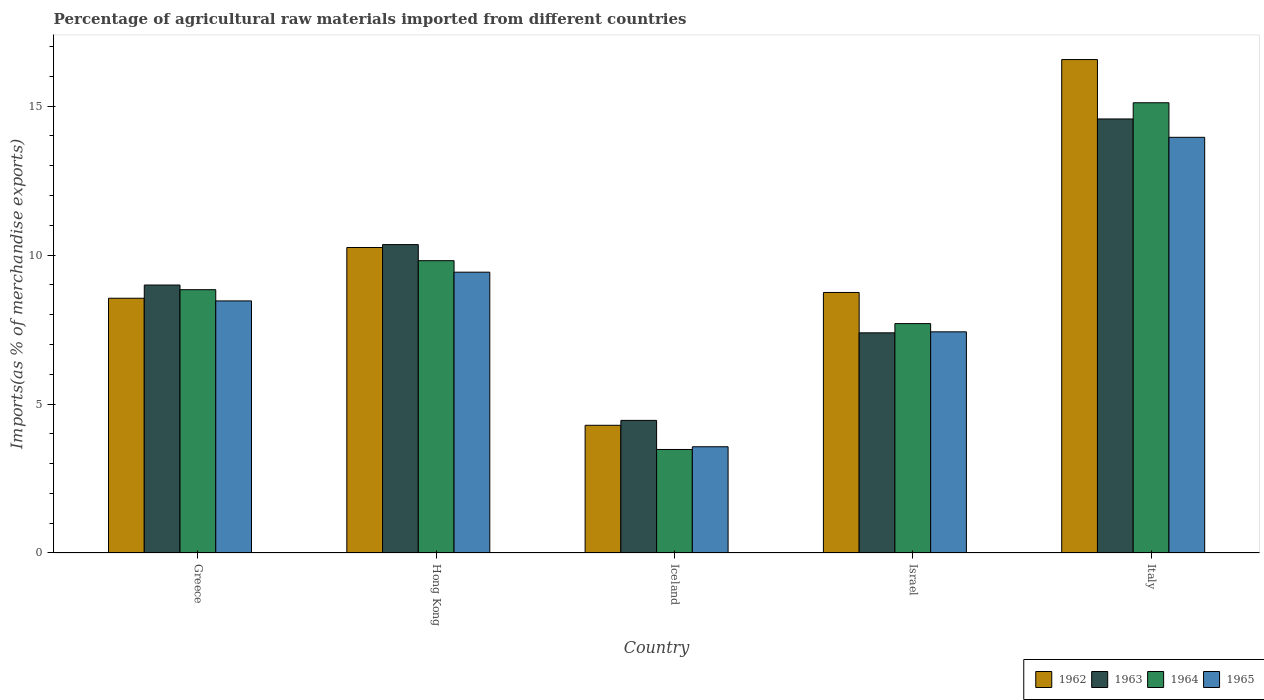How many groups of bars are there?
Make the answer very short. 5. Are the number of bars per tick equal to the number of legend labels?
Keep it short and to the point. Yes. What is the label of the 1st group of bars from the left?
Give a very brief answer. Greece. In how many cases, is the number of bars for a given country not equal to the number of legend labels?
Provide a succinct answer. 0. What is the percentage of imports to different countries in 1962 in Greece?
Give a very brief answer. 8.55. Across all countries, what is the maximum percentage of imports to different countries in 1963?
Your answer should be very brief. 14.57. Across all countries, what is the minimum percentage of imports to different countries in 1964?
Your answer should be very brief. 3.48. What is the total percentage of imports to different countries in 1962 in the graph?
Make the answer very short. 48.41. What is the difference between the percentage of imports to different countries in 1963 in Israel and that in Italy?
Ensure brevity in your answer.  -7.18. What is the difference between the percentage of imports to different countries in 1965 in Israel and the percentage of imports to different countries in 1962 in Italy?
Provide a short and direct response. -9.14. What is the average percentage of imports to different countries in 1964 per country?
Provide a short and direct response. 8.99. What is the difference between the percentage of imports to different countries of/in 1965 and percentage of imports to different countries of/in 1962 in Israel?
Make the answer very short. -1.32. What is the ratio of the percentage of imports to different countries in 1962 in Greece to that in Israel?
Give a very brief answer. 0.98. Is the difference between the percentage of imports to different countries in 1965 in Greece and Italy greater than the difference between the percentage of imports to different countries in 1962 in Greece and Italy?
Make the answer very short. Yes. What is the difference between the highest and the second highest percentage of imports to different countries in 1964?
Offer a terse response. -0.97. What is the difference between the highest and the lowest percentage of imports to different countries in 1963?
Provide a succinct answer. 10.12. In how many countries, is the percentage of imports to different countries in 1964 greater than the average percentage of imports to different countries in 1964 taken over all countries?
Your response must be concise. 2. Is the sum of the percentage of imports to different countries in 1963 in Iceland and Israel greater than the maximum percentage of imports to different countries in 1965 across all countries?
Give a very brief answer. No. What does the 4th bar from the left in Iceland represents?
Give a very brief answer. 1965. How many bars are there?
Offer a terse response. 20. Are all the bars in the graph horizontal?
Your answer should be compact. No. How many countries are there in the graph?
Your response must be concise. 5. What is the difference between two consecutive major ticks on the Y-axis?
Provide a succinct answer. 5. How many legend labels are there?
Ensure brevity in your answer.  4. What is the title of the graph?
Offer a terse response. Percentage of agricultural raw materials imported from different countries. What is the label or title of the X-axis?
Offer a terse response. Country. What is the label or title of the Y-axis?
Provide a succinct answer. Imports(as % of merchandise exports). What is the Imports(as % of merchandise exports) of 1962 in Greece?
Keep it short and to the point. 8.55. What is the Imports(as % of merchandise exports) of 1963 in Greece?
Your answer should be very brief. 9. What is the Imports(as % of merchandise exports) of 1964 in Greece?
Your answer should be compact. 8.84. What is the Imports(as % of merchandise exports) of 1965 in Greece?
Make the answer very short. 8.46. What is the Imports(as % of merchandise exports) of 1962 in Hong Kong?
Offer a terse response. 10.26. What is the Imports(as % of merchandise exports) of 1963 in Hong Kong?
Provide a short and direct response. 10.35. What is the Imports(as % of merchandise exports) of 1964 in Hong Kong?
Offer a terse response. 9.81. What is the Imports(as % of merchandise exports) in 1965 in Hong Kong?
Offer a very short reply. 9.43. What is the Imports(as % of merchandise exports) of 1962 in Iceland?
Offer a very short reply. 4.29. What is the Imports(as % of merchandise exports) of 1963 in Iceland?
Provide a succinct answer. 4.45. What is the Imports(as % of merchandise exports) of 1964 in Iceland?
Provide a short and direct response. 3.48. What is the Imports(as % of merchandise exports) of 1965 in Iceland?
Provide a short and direct response. 3.57. What is the Imports(as % of merchandise exports) of 1962 in Israel?
Provide a short and direct response. 8.75. What is the Imports(as % of merchandise exports) in 1963 in Israel?
Offer a terse response. 7.39. What is the Imports(as % of merchandise exports) of 1964 in Israel?
Give a very brief answer. 7.7. What is the Imports(as % of merchandise exports) in 1965 in Israel?
Your answer should be very brief. 7.42. What is the Imports(as % of merchandise exports) in 1962 in Italy?
Provide a short and direct response. 16.57. What is the Imports(as % of merchandise exports) of 1963 in Italy?
Give a very brief answer. 14.57. What is the Imports(as % of merchandise exports) of 1964 in Italy?
Offer a very short reply. 15.12. What is the Imports(as % of merchandise exports) of 1965 in Italy?
Make the answer very short. 13.95. Across all countries, what is the maximum Imports(as % of merchandise exports) in 1962?
Give a very brief answer. 16.57. Across all countries, what is the maximum Imports(as % of merchandise exports) in 1963?
Your answer should be compact. 14.57. Across all countries, what is the maximum Imports(as % of merchandise exports) of 1964?
Make the answer very short. 15.12. Across all countries, what is the maximum Imports(as % of merchandise exports) of 1965?
Offer a terse response. 13.95. Across all countries, what is the minimum Imports(as % of merchandise exports) of 1962?
Provide a short and direct response. 4.29. Across all countries, what is the minimum Imports(as % of merchandise exports) in 1963?
Provide a short and direct response. 4.45. Across all countries, what is the minimum Imports(as % of merchandise exports) of 1964?
Give a very brief answer. 3.48. Across all countries, what is the minimum Imports(as % of merchandise exports) of 1965?
Ensure brevity in your answer.  3.57. What is the total Imports(as % of merchandise exports) of 1962 in the graph?
Your response must be concise. 48.41. What is the total Imports(as % of merchandise exports) in 1963 in the graph?
Your answer should be compact. 45.76. What is the total Imports(as % of merchandise exports) of 1964 in the graph?
Offer a terse response. 44.94. What is the total Imports(as % of merchandise exports) in 1965 in the graph?
Provide a short and direct response. 42.84. What is the difference between the Imports(as % of merchandise exports) of 1962 in Greece and that in Hong Kong?
Your answer should be very brief. -1.7. What is the difference between the Imports(as % of merchandise exports) in 1963 in Greece and that in Hong Kong?
Ensure brevity in your answer.  -1.36. What is the difference between the Imports(as % of merchandise exports) of 1964 in Greece and that in Hong Kong?
Provide a short and direct response. -0.97. What is the difference between the Imports(as % of merchandise exports) of 1965 in Greece and that in Hong Kong?
Your answer should be compact. -0.96. What is the difference between the Imports(as % of merchandise exports) of 1962 in Greece and that in Iceland?
Give a very brief answer. 4.26. What is the difference between the Imports(as % of merchandise exports) of 1963 in Greece and that in Iceland?
Offer a very short reply. 4.54. What is the difference between the Imports(as % of merchandise exports) of 1964 in Greece and that in Iceland?
Give a very brief answer. 5.36. What is the difference between the Imports(as % of merchandise exports) of 1965 in Greece and that in Iceland?
Give a very brief answer. 4.9. What is the difference between the Imports(as % of merchandise exports) in 1962 in Greece and that in Israel?
Offer a terse response. -0.19. What is the difference between the Imports(as % of merchandise exports) in 1963 in Greece and that in Israel?
Offer a very short reply. 1.6. What is the difference between the Imports(as % of merchandise exports) in 1964 in Greece and that in Israel?
Give a very brief answer. 1.14. What is the difference between the Imports(as % of merchandise exports) of 1965 in Greece and that in Israel?
Offer a very short reply. 1.04. What is the difference between the Imports(as % of merchandise exports) of 1962 in Greece and that in Italy?
Provide a short and direct response. -8.01. What is the difference between the Imports(as % of merchandise exports) of 1963 in Greece and that in Italy?
Your answer should be very brief. -5.58. What is the difference between the Imports(as % of merchandise exports) in 1964 in Greece and that in Italy?
Ensure brevity in your answer.  -6.28. What is the difference between the Imports(as % of merchandise exports) of 1965 in Greece and that in Italy?
Make the answer very short. -5.49. What is the difference between the Imports(as % of merchandise exports) of 1962 in Hong Kong and that in Iceland?
Keep it short and to the point. 5.97. What is the difference between the Imports(as % of merchandise exports) in 1963 in Hong Kong and that in Iceland?
Your response must be concise. 5.9. What is the difference between the Imports(as % of merchandise exports) of 1964 in Hong Kong and that in Iceland?
Provide a succinct answer. 6.34. What is the difference between the Imports(as % of merchandise exports) in 1965 in Hong Kong and that in Iceland?
Your answer should be very brief. 5.86. What is the difference between the Imports(as % of merchandise exports) in 1962 in Hong Kong and that in Israel?
Provide a short and direct response. 1.51. What is the difference between the Imports(as % of merchandise exports) in 1963 in Hong Kong and that in Israel?
Give a very brief answer. 2.96. What is the difference between the Imports(as % of merchandise exports) of 1964 in Hong Kong and that in Israel?
Provide a succinct answer. 2.11. What is the difference between the Imports(as % of merchandise exports) in 1965 in Hong Kong and that in Israel?
Provide a succinct answer. 2. What is the difference between the Imports(as % of merchandise exports) of 1962 in Hong Kong and that in Italy?
Your answer should be compact. -6.31. What is the difference between the Imports(as % of merchandise exports) of 1963 in Hong Kong and that in Italy?
Ensure brevity in your answer.  -4.22. What is the difference between the Imports(as % of merchandise exports) in 1964 in Hong Kong and that in Italy?
Keep it short and to the point. -5.3. What is the difference between the Imports(as % of merchandise exports) of 1965 in Hong Kong and that in Italy?
Your answer should be compact. -4.53. What is the difference between the Imports(as % of merchandise exports) of 1962 in Iceland and that in Israel?
Keep it short and to the point. -4.46. What is the difference between the Imports(as % of merchandise exports) of 1963 in Iceland and that in Israel?
Your response must be concise. -2.94. What is the difference between the Imports(as % of merchandise exports) in 1964 in Iceland and that in Israel?
Provide a succinct answer. -4.23. What is the difference between the Imports(as % of merchandise exports) in 1965 in Iceland and that in Israel?
Your answer should be very brief. -3.86. What is the difference between the Imports(as % of merchandise exports) of 1962 in Iceland and that in Italy?
Make the answer very short. -12.28. What is the difference between the Imports(as % of merchandise exports) of 1963 in Iceland and that in Italy?
Make the answer very short. -10.12. What is the difference between the Imports(as % of merchandise exports) of 1964 in Iceland and that in Italy?
Make the answer very short. -11.64. What is the difference between the Imports(as % of merchandise exports) of 1965 in Iceland and that in Italy?
Your response must be concise. -10.39. What is the difference between the Imports(as % of merchandise exports) of 1962 in Israel and that in Italy?
Offer a very short reply. -7.82. What is the difference between the Imports(as % of merchandise exports) in 1963 in Israel and that in Italy?
Ensure brevity in your answer.  -7.18. What is the difference between the Imports(as % of merchandise exports) in 1964 in Israel and that in Italy?
Your response must be concise. -7.41. What is the difference between the Imports(as % of merchandise exports) of 1965 in Israel and that in Italy?
Ensure brevity in your answer.  -6.53. What is the difference between the Imports(as % of merchandise exports) of 1962 in Greece and the Imports(as % of merchandise exports) of 1963 in Hong Kong?
Offer a very short reply. -1.8. What is the difference between the Imports(as % of merchandise exports) of 1962 in Greece and the Imports(as % of merchandise exports) of 1964 in Hong Kong?
Your answer should be very brief. -1.26. What is the difference between the Imports(as % of merchandise exports) of 1962 in Greece and the Imports(as % of merchandise exports) of 1965 in Hong Kong?
Provide a short and direct response. -0.88. What is the difference between the Imports(as % of merchandise exports) in 1963 in Greece and the Imports(as % of merchandise exports) in 1964 in Hong Kong?
Ensure brevity in your answer.  -0.82. What is the difference between the Imports(as % of merchandise exports) in 1963 in Greece and the Imports(as % of merchandise exports) in 1965 in Hong Kong?
Give a very brief answer. -0.43. What is the difference between the Imports(as % of merchandise exports) in 1964 in Greece and the Imports(as % of merchandise exports) in 1965 in Hong Kong?
Provide a short and direct response. -0.59. What is the difference between the Imports(as % of merchandise exports) in 1962 in Greece and the Imports(as % of merchandise exports) in 1963 in Iceland?
Your answer should be very brief. 4.1. What is the difference between the Imports(as % of merchandise exports) in 1962 in Greece and the Imports(as % of merchandise exports) in 1964 in Iceland?
Offer a terse response. 5.08. What is the difference between the Imports(as % of merchandise exports) in 1962 in Greece and the Imports(as % of merchandise exports) in 1965 in Iceland?
Make the answer very short. 4.99. What is the difference between the Imports(as % of merchandise exports) of 1963 in Greece and the Imports(as % of merchandise exports) of 1964 in Iceland?
Your answer should be very brief. 5.52. What is the difference between the Imports(as % of merchandise exports) in 1963 in Greece and the Imports(as % of merchandise exports) in 1965 in Iceland?
Your answer should be compact. 5.43. What is the difference between the Imports(as % of merchandise exports) in 1964 in Greece and the Imports(as % of merchandise exports) in 1965 in Iceland?
Your answer should be compact. 5.27. What is the difference between the Imports(as % of merchandise exports) of 1962 in Greece and the Imports(as % of merchandise exports) of 1963 in Israel?
Make the answer very short. 1.16. What is the difference between the Imports(as % of merchandise exports) of 1962 in Greece and the Imports(as % of merchandise exports) of 1964 in Israel?
Your response must be concise. 0.85. What is the difference between the Imports(as % of merchandise exports) in 1962 in Greece and the Imports(as % of merchandise exports) in 1965 in Israel?
Keep it short and to the point. 1.13. What is the difference between the Imports(as % of merchandise exports) in 1963 in Greece and the Imports(as % of merchandise exports) in 1964 in Israel?
Provide a succinct answer. 1.3. What is the difference between the Imports(as % of merchandise exports) of 1963 in Greece and the Imports(as % of merchandise exports) of 1965 in Israel?
Keep it short and to the point. 1.57. What is the difference between the Imports(as % of merchandise exports) in 1964 in Greece and the Imports(as % of merchandise exports) in 1965 in Israel?
Ensure brevity in your answer.  1.42. What is the difference between the Imports(as % of merchandise exports) in 1962 in Greece and the Imports(as % of merchandise exports) in 1963 in Italy?
Your answer should be very brief. -6.02. What is the difference between the Imports(as % of merchandise exports) of 1962 in Greece and the Imports(as % of merchandise exports) of 1964 in Italy?
Make the answer very short. -6.56. What is the difference between the Imports(as % of merchandise exports) in 1962 in Greece and the Imports(as % of merchandise exports) in 1965 in Italy?
Ensure brevity in your answer.  -5.4. What is the difference between the Imports(as % of merchandise exports) of 1963 in Greece and the Imports(as % of merchandise exports) of 1964 in Italy?
Your answer should be very brief. -6.12. What is the difference between the Imports(as % of merchandise exports) in 1963 in Greece and the Imports(as % of merchandise exports) in 1965 in Italy?
Ensure brevity in your answer.  -4.96. What is the difference between the Imports(as % of merchandise exports) in 1964 in Greece and the Imports(as % of merchandise exports) in 1965 in Italy?
Make the answer very short. -5.12. What is the difference between the Imports(as % of merchandise exports) in 1962 in Hong Kong and the Imports(as % of merchandise exports) in 1963 in Iceland?
Make the answer very short. 5.8. What is the difference between the Imports(as % of merchandise exports) of 1962 in Hong Kong and the Imports(as % of merchandise exports) of 1964 in Iceland?
Offer a very short reply. 6.78. What is the difference between the Imports(as % of merchandise exports) of 1962 in Hong Kong and the Imports(as % of merchandise exports) of 1965 in Iceland?
Offer a terse response. 6.69. What is the difference between the Imports(as % of merchandise exports) in 1963 in Hong Kong and the Imports(as % of merchandise exports) in 1964 in Iceland?
Provide a succinct answer. 6.88. What is the difference between the Imports(as % of merchandise exports) in 1963 in Hong Kong and the Imports(as % of merchandise exports) in 1965 in Iceland?
Offer a very short reply. 6.79. What is the difference between the Imports(as % of merchandise exports) in 1964 in Hong Kong and the Imports(as % of merchandise exports) in 1965 in Iceland?
Ensure brevity in your answer.  6.25. What is the difference between the Imports(as % of merchandise exports) of 1962 in Hong Kong and the Imports(as % of merchandise exports) of 1963 in Israel?
Provide a succinct answer. 2.86. What is the difference between the Imports(as % of merchandise exports) in 1962 in Hong Kong and the Imports(as % of merchandise exports) in 1964 in Israel?
Provide a short and direct response. 2.55. What is the difference between the Imports(as % of merchandise exports) in 1962 in Hong Kong and the Imports(as % of merchandise exports) in 1965 in Israel?
Provide a succinct answer. 2.83. What is the difference between the Imports(as % of merchandise exports) of 1963 in Hong Kong and the Imports(as % of merchandise exports) of 1964 in Israel?
Ensure brevity in your answer.  2.65. What is the difference between the Imports(as % of merchandise exports) in 1963 in Hong Kong and the Imports(as % of merchandise exports) in 1965 in Israel?
Your answer should be compact. 2.93. What is the difference between the Imports(as % of merchandise exports) of 1964 in Hong Kong and the Imports(as % of merchandise exports) of 1965 in Israel?
Your answer should be compact. 2.39. What is the difference between the Imports(as % of merchandise exports) of 1962 in Hong Kong and the Imports(as % of merchandise exports) of 1963 in Italy?
Keep it short and to the point. -4.32. What is the difference between the Imports(as % of merchandise exports) in 1962 in Hong Kong and the Imports(as % of merchandise exports) in 1964 in Italy?
Ensure brevity in your answer.  -4.86. What is the difference between the Imports(as % of merchandise exports) of 1962 in Hong Kong and the Imports(as % of merchandise exports) of 1965 in Italy?
Your response must be concise. -3.7. What is the difference between the Imports(as % of merchandise exports) of 1963 in Hong Kong and the Imports(as % of merchandise exports) of 1964 in Italy?
Your answer should be very brief. -4.76. What is the difference between the Imports(as % of merchandise exports) of 1963 in Hong Kong and the Imports(as % of merchandise exports) of 1965 in Italy?
Your response must be concise. -3.6. What is the difference between the Imports(as % of merchandise exports) in 1964 in Hong Kong and the Imports(as % of merchandise exports) in 1965 in Italy?
Ensure brevity in your answer.  -4.14. What is the difference between the Imports(as % of merchandise exports) of 1962 in Iceland and the Imports(as % of merchandise exports) of 1963 in Israel?
Give a very brief answer. -3.1. What is the difference between the Imports(as % of merchandise exports) in 1962 in Iceland and the Imports(as % of merchandise exports) in 1964 in Israel?
Your answer should be very brief. -3.41. What is the difference between the Imports(as % of merchandise exports) of 1962 in Iceland and the Imports(as % of merchandise exports) of 1965 in Israel?
Your answer should be very brief. -3.14. What is the difference between the Imports(as % of merchandise exports) in 1963 in Iceland and the Imports(as % of merchandise exports) in 1964 in Israel?
Your answer should be very brief. -3.25. What is the difference between the Imports(as % of merchandise exports) in 1963 in Iceland and the Imports(as % of merchandise exports) in 1965 in Israel?
Ensure brevity in your answer.  -2.97. What is the difference between the Imports(as % of merchandise exports) in 1964 in Iceland and the Imports(as % of merchandise exports) in 1965 in Israel?
Give a very brief answer. -3.95. What is the difference between the Imports(as % of merchandise exports) in 1962 in Iceland and the Imports(as % of merchandise exports) in 1963 in Italy?
Provide a short and direct response. -10.28. What is the difference between the Imports(as % of merchandise exports) of 1962 in Iceland and the Imports(as % of merchandise exports) of 1964 in Italy?
Offer a terse response. -10.83. What is the difference between the Imports(as % of merchandise exports) in 1962 in Iceland and the Imports(as % of merchandise exports) in 1965 in Italy?
Give a very brief answer. -9.67. What is the difference between the Imports(as % of merchandise exports) of 1963 in Iceland and the Imports(as % of merchandise exports) of 1964 in Italy?
Offer a terse response. -10.66. What is the difference between the Imports(as % of merchandise exports) in 1963 in Iceland and the Imports(as % of merchandise exports) in 1965 in Italy?
Offer a very short reply. -9.5. What is the difference between the Imports(as % of merchandise exports) of 1964 in Iceland and the Imports(as % of merchandise exports) of 1965 in Italy?
Offer a very short reply. -10.48. What is the difference between the Imports(as % of merchandise exports) of 1962 in Israel and the Imports(as % of merchandise exports) of 1963 in Italy?
Your response must be concise. -5.83. What is the difference between the Imports(as % of merchandise exports) in 1962 in Israel and the Imports(as % of merchandise exports) in 1964 in Italy?
Keep it short and to the point. -6.37. What is the difference between the Imports(as % of merchandise exports) in 1962 in Israel and the Imports(as % of merchandise exports) in 1965 in Italy?
Offer a very short reply. -5.21. What is the difference between the Imports(as % of merchandise exports) in 1963 in Israel and the Imports(as % of merchandise exports) in 1964 in Italy?
Give a very brief answer. -7.72. What is the difference between the Imports(as % of merchandise exports) of 1963 in Israel and the Imports(as % of merchandise exports) of 1965 in Italy?
Offer a terse response. -6.56. What is the difference between the Imports(as % of merchandise exports) of 1964 in Israel and the Imports(as % of merchandise exports) of 1965 in Italy?
Offer a very short reply. -6.25. What is the average Imports(as % of merchandise exports) of 1962 per country?
Keep it short and to the point. 9.68. What is the average Imports(as % of merchandise exports) of 1963 per country?
Keep it short and to the point. 9.15. What is the average Imports(as % of merchandise exports) of 1964 per country?
Give a very brief answer. 8.99. What is the average Imports(as % of merchandise exports) of 1965 per country?
Offer a terse response. 8.57. What is the difference between the Imports(as % of merchandise exports) in 1962 and Imports(as % of merchandise exports) in 1963 in Greece?
Offer a very short reply. -0.44. What is the difference between the Imports(as % of merchandise exports) in 1962 and Imports(as % of merchandise exports) in 1964 in Greece?
Provide a succinct answer. -0.29. What is the difference between the Imports(as % of merchandise exports) in 1962 and Imports(as % of merchandise exports) in 1965 in Greece?
Your response must be concise. 0.09. What is the difference between the Imports(as % of merchandise exports) of 1963 and Imports(as % of merchandise exports) of 1964 in Greece?
Make the answer very short. 0.16. What is the difference between the Imports(as % of merchandise exports) of 1963 and Imports(as % of merchandise exports) of 1965 in Greece?
Offer a terse response. 0.53. What is the difference between the Imports(as % of merchandise exports) of 1964 and Imports(as % of merchandise exports) of 1965 in Greece?
Your response must be concise. 0.38. What is the difference between the Imports(as % of merchandise exports) in 1962 and Imports(as % of merchandise exports) in 1963 in Hong Kong?
Make the answer very short. -0.1. What is the difference between the Imports(as % of merchandise exports) in 1962 and Imports(as % of merchandise exports) in 1964 in Hong Kong?
Make the answer very short. 0.44. What is the difference between the Imports(as % of merchandise exports) of 1962 and Imports(as % of merchandise exports) of 1965 in Hong Kong?
Give a very brief answer. 0.83. What is the difference between the Imports(as % of merchandise exports) of 1963 and Imports(as % of merchandise exports) of 1964 in Hong Kong?
Give a very brief answer. 0.54. What is the difference between the Imports(as % of merchandise exports) in 1963 and Imports(as % of merchandise exports) in 1965 in Hong Kong?
Provide a succinct answer. 0.93. What is the difference between the Imports(as % of merchandise exports) in 1964 and Imports(as % of merchandise exports) in 1965 in Hong Kong?
Offer a very short reply. 0.39. What is the difference between the Imports(as % of merchandise exports) in 1962 and Imports(as % of merchandise exports) in 1963 in Iceland?
Make the answer very short. -0.16. What is the difference between the Imports(as % of merchandise exports) of 1962 and Imports(as % of merchandise exports) of 1964 in Iceland?
Your answer should be very brief. 0.81. What is the difference between the Imports(as % of merchandise exports) in 1962 and Imports(as % of merchandise exports) in 1965 in Iceland?
Give a very brief answer. 0.72. What is the difference between the Imports(as % of merchandise exports) in 1963 and Imports(as % of merchandise exports) in 1964 in Iceland?
Give a very brief answer. 0.98. What is the difference between the Imports(as % of merchandise exports) in 1963 and Imports(as % of merchandise exports) in 1965 in Iceland?
Offer a terse response. 0.89. What is the difference between the Imports(as % of merchandise exports) of 1964 and Imports(as % of merchandise exports) of 1965 in Iceland?
Offer a terse response. -0.09. What is the difference between the Imports(as % of merchandise exports) in 1962 and Imports(as % of merchandise exports) in 1963 in Israel?
Your response must be concise. 1.36. What is the difference between the Imports(as % of merchandise exports) of 1962 and Imports(as % of merchandise exports) of 1964 in Israel?
Offer a very short reply. 1.05. What is the difference between the Imports(as % of merchandise exports) of 1962 and Imports(as % of merchandise exports) of 1965 in Israel?
Offer a very short reply. 1.32. What is the difference between the Imports(as % of merchandise exports) of 1963 and Imports(as % of merchandise exports) of 1964 in Israel?
Your answer should be compact. -0.31. What is the difference between the Imports(as % of merchandise exports) of 1963 and Imports(as % of merchandise exports) of 1965 in Israel?
Your response must be concise. -0.03. What is the difference between the Imports(as % of merchandise exports) in 1964 and Imports(as % of merchandise exports) in 1965 in Israel?
Keep it short and to the point. 0.28. What is the difference between the Imports(as % of merchandise exports) in 1962 and Imports(as % of merchandise exports) in 1963 in Italy?
Offer a terse response. 1.99. What is the difference between the Imports(as % of merchandise exports) of 1962 and Imports(as % of merchandise exports) of 1964 in Italy?
Provide a short and direct response. 1.45. What is the difference between the Imports(as % of merchandise exports) of 1962 and Imports(as % of merchandise exports) of 1965 in Italy?
Your response must be concise. 2.61. What is the difference between the Imports(as % of merchandise exports) of 1963 and Imports(as % of merchandise exports) of 1964 in Italy?
Keep it short and to the point. -0.54. What is the difference between the Imports(as % of merchandise exports) in 1963 and Imports(as % of merchandise exports) in 1965 in Italy?
Offer a terse response. 0.62. What is the difference between the Imports(as % of merchandise exports) of 1964 and Imports(as % of merchandise exports) of 1965 in Italy?
Give a very brief answer. 1.16. What is the ratio of the Imports(as % of merchandise exports) of 1962 in Greece to that in Hong Kong?
Provide a succinct answer. 0.83. What is the ratio of the Imports(as % of merchandise exports) of 1963 in Greece to that in Hong Kong?
Give a very brief answer. 0.87. What is the ratio of the Imports(as % of merchandise exports) in 1964 in Greece to that in Hong Kong?
Your answer should be compact. 0.9. What is the ratio of the Imports(as % of merchandise exports) of 1965 in Greece to that in Hong Kong?
Give a very brief answer. 0.9. What is the ratio of the Imports(as % of merchandise exports) of 1962 in Greece to that in Iceland?
Offer a very short reply. 1.99. What is the ratio of the Imports(as % of merchandise exports) of 1963 in Greece to that in Iceland?
Provide a short and direct response. 2.02. What is the ratio of the Imports(as % of merchandise exports) of 1964 in Greece to that in Iceland?
Ensure brevity in your answer.  2.54. What is the ratio of the Imports(as % of merchandise exports) in 1965 in Greece to that in Iceland?
Provide a short and direct response. 2.37. What is the ratio of the Imports(as % of merchandise exports) in 1962 in Greece to that in Israel?
Make the answer very short. 0.98. What is the ratio of the Imports(as % of merchandise exports) of 1963 in Greece to that in Israel?
Keep it short and to the point. 1.22. What is the ratio of the Imports(as % of merchandise exports) in 1964 in Greece to that in Israel?
Give a very brief answer. 1.15. What is the ratio of the Imports(as % of merchandise exports) in 1965 in Greece to that in Israel?
Offer a terse response. 1.14. What is the ratio of the Imports(as % of merchandise exports) in 1962 in Greece to that in Italy?
Ensure brevity in your answer.  0.52. What is the ratio of the Imports(as % of merchandise exports) of 1963 in Greece to that in Italy?
Provide a short and direct response. 0.62. What is the ratio of the Imports(as % of merchandise exports) of 1964 in Greece to that in Italy?
Give a very brief answer. 0.58. What is the ratio of the Imports(as % of merchandise exports) in 1965 in Greece to that in Italy?
Provide a succinct answer. 0.61. What is the ratio of the Imports(as % of merchandise exports) in 1962 in Hong Kong to that in Iceland?
Offer a very short reply. 2.39. What is the ratio of the Imports(as % of merchandise exports) in 1963 in Hong Kong to that in Iceland?
Your answer should be compact. 2.33. What is the ratio of the Imports(as % of merchandise exports) of 1964 in Hong Kong to that in Iceland?
Keep it short and to the point. 2.82. What is the ratio of the Imports(as % of merchandise exports) of 1965 in Hong Kong to that in Iceland?
Offer a terse response. 2.64. What is the ratio of the Imports(as % of merchandise exports) in 1962 in Hong Kong to that in Israel?
Your answer should be very brief. 1.17. What is the ratio of the Imports(as % of merchandise exports) of 1963 in Hong Kong to that in Israel?
Provide a succinct answer. 1.4. What is the ratio of the Imports(as % of merchandise exports) in 1964 in Hong Kong to that in Israel?
Provide a short and direct response. 1.27. What is the ratio of the Imports(as % of merchandise exports) of 1965 in Hong Kong to that in Israel?
Your answer should be compact. 1.27. What is the ratio of the Imports(as % of merchandise exports) in 1962 in Hong Kong to that in Italy?
Your answer should be compact. 0.62. What is the ratio of the Imports(as % of merchandise exports) in 1963 in Hong Kong to that in Italy?
Give a very brief answer. 0.71. What is the ratio of the Imports(as % of merchandise exports) in 1964 in Hong Kong to that in Italy?
Make the answer very short. 0.65. What is the ratio of the Imports(as % of merchandise exports) in 1965 in Hong Kong to that in Italy?
Your answer should be very brief. 0.68. What is the ratio of the Imports(as % of merchandise exports) of 1962 in Iceland to that in Israel?
Your response must be concise. 0.49. What is the ratio of the Imports(as % of merchandise exports) of 1963 in Iceland to that in Israel?
Offer a terse response. 0.6. What is the ratio of the Imports(as % of merchandise exports) in 1964 in Iceland to that in Israel?
Give a very brief answer. 0.45. What is the ratio of the Imports(as % of merchandise exports) in 1965 in Iceland to that in Israel?
Provide a succinct answer. 0.48. What is the ratio of the Imports(as % of merchandise exports) of 1962 in Iceland to that in Italy?
Provide a short and direct response. 0.26. What is the ratio of the Imports(as % of merchandise exports) in 1963 in Iceland to that in Italy?
Your answer should be very brief. 0.31. What is the ratio of the Imports(as % of merchandise exports) in 1964 in Iceland to that in Italy?
Keep it short and to the point. 0.23. What is the ratio of the Imports(as % of merchandise exports) in 1965 in Iceland to that in Italy?
Your answer should be very brief. 0.26. What is the ratio of the Imports(as % of merchandise exports) of 1962 in Israel to that in Italy?
Your answer should be very brief. 0.53. What is the ratio of the Imports(as % of merchandise exports) in 1963 in Israel to that in Italy?
Provide a short and direct response. 0.51. What is the ratio of the Imports(as % of merchandise exports) of 1964 in Israel to that in Italy?
Keep it short and to the point. 0.51. What is the ratio of the Imports(as % of merchandise exports) of 1965 in Israel to that in Italy?
Keep it short and to the point. 0.53. What is the difference between the highest and the second highest Imports(as % of merchandise exports) of 1962?
Offer a very short reply. 6.31. What is the difference between the highest and the second highest Imports(as % of merchandise exports) in 1963?
Provide a succinct answer. 4.22. What is the difference between the highest and the second highest Imports(as % of merchandise exports) in 1964?
Your answer should be compact. 5.3. What is the difference between the highest and the second highest Imports(as % of merchandise exports) in 1965?
Offer a very short reply. 4.53. What is the difference between the highest and the lowest Imports(as % of merchandise exports) in 1962?
Your answer should be very brief. 12.28. What is the difference between the highest and the lowest Imports(as % of merchandise exports) of 1963?
Offer a very short reply. 10.12. What is the difference between the highest and the lowest Imports(as % of merchandise exports) of 1964?
Make the answer very short. 11.64. What is the difference between the highest and the lowest Imports(as % of merchandise exports) in 1965?
Your response must be concise. 10.39. 